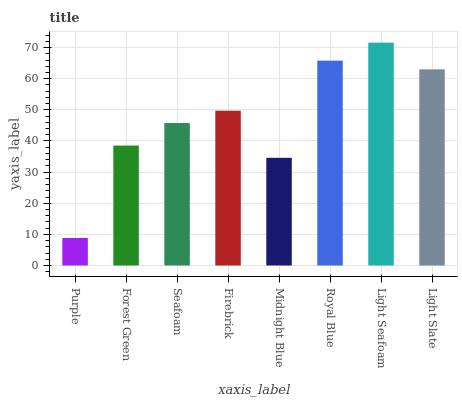Is Purple the minimum?
Answer yes or no. Yes. Is Light Seafoam the maximum?
Answer yes or no. Yes. Is Forest Green the minimum?
Answer yes or no. No. Is Forest Green the maximum?
Answer yes or no. No. Is Forest Green greater than Purple?
Answer yes or no. Yes. Is Purple less than Forest Green?
Answer yes or no. Yes. Is Purple greater than Forest Green?
Answer yes or no. No. Is Forest Green less than Purple?
Answer yes or no. No. Is Firebrick the high median?
Answer yes or no. Yes. Is Seafoam the low median?
Answer yes or no. Yes. Is Royal Blue the high median?
Answer yes or no. No. Is Forest Green the low median?
Answer yes or no. No. 